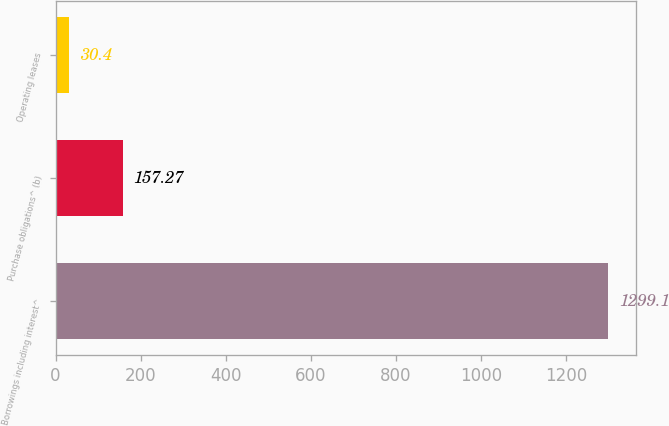Convert chart to OTSL. <chart><loc_0><loc_0><loc_500><loc_500><bar_chart><fcel>Borrowings including interest^<fcel>Purchase obligations^ (b)<fcel>Operating leases<nl><fcel>1299.1<fcel>157.27<fcel>30.4<nl></chart> 